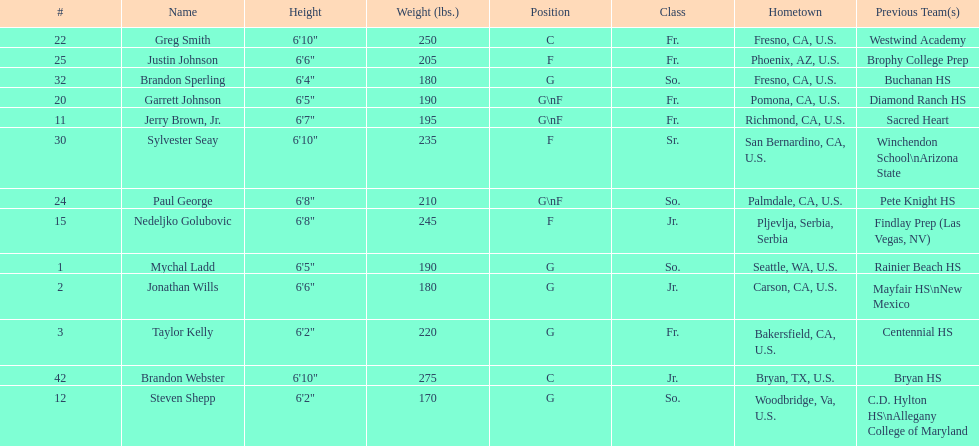Taylor kelly is shorter than 6' 3", which other player is also shorter than 6' 3"? Steven Shepp. 